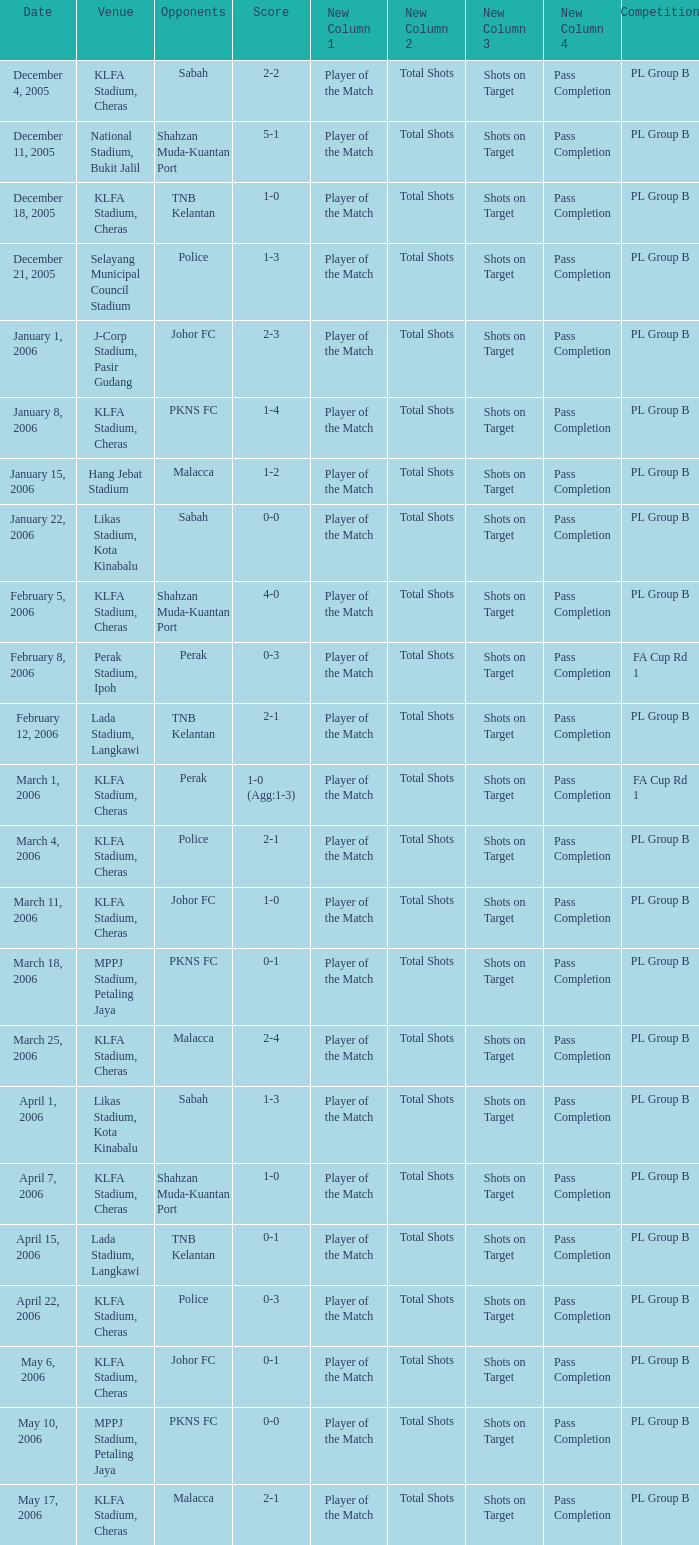Who competed on may 6, 2006? Johor FC. 